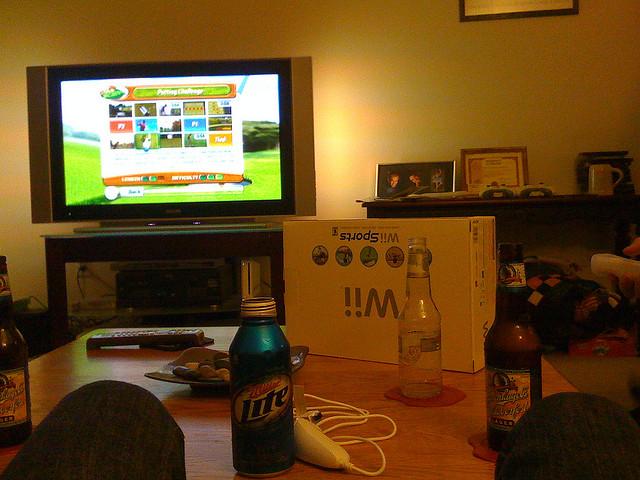Can you see a person's knees?
Quick response, please. Yes. What brand of game are they playing?
Write a very short answer. Wii. What are the players drinking?
Quick response, please. Beer. 